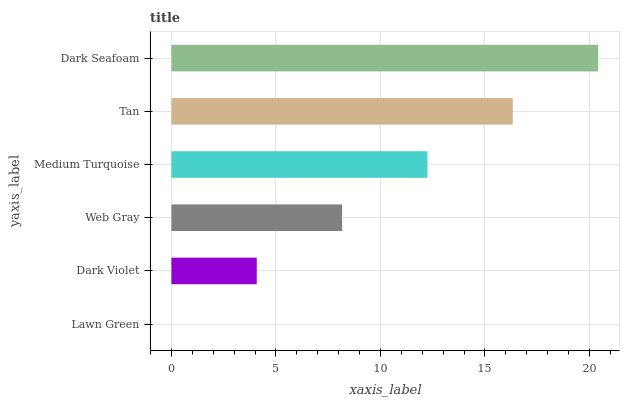Is Lawn Green the minimum?
Answer yes or no. Yes. Is Dark Seafoam the maximum?
Answer yes or no. Yes. Is Dark Violet the minimum?
Answer yes or no. No. Is Dark Violet the maximum?
Answer yes or no. No. Is Dark Violet greater than Lawn Green?
Answer yes or no. Yes. Is Lawn Green less than Dark Violet?
Answer yes or no. Yes. Is Lawn Green greater than Dark Violet?
Answer yes or no. No. Is Dark Violet less than Lawn Green?
Answer yes or no. No. Is Medium Turquoise the high median?
Answer yes or no. Yes. Is Web Gray the low median?
Answer yes or no. Yes. Is Web Gray the high median?
Answer yes or no. No. Is Tan the low median?
Answer yes or no. No. 